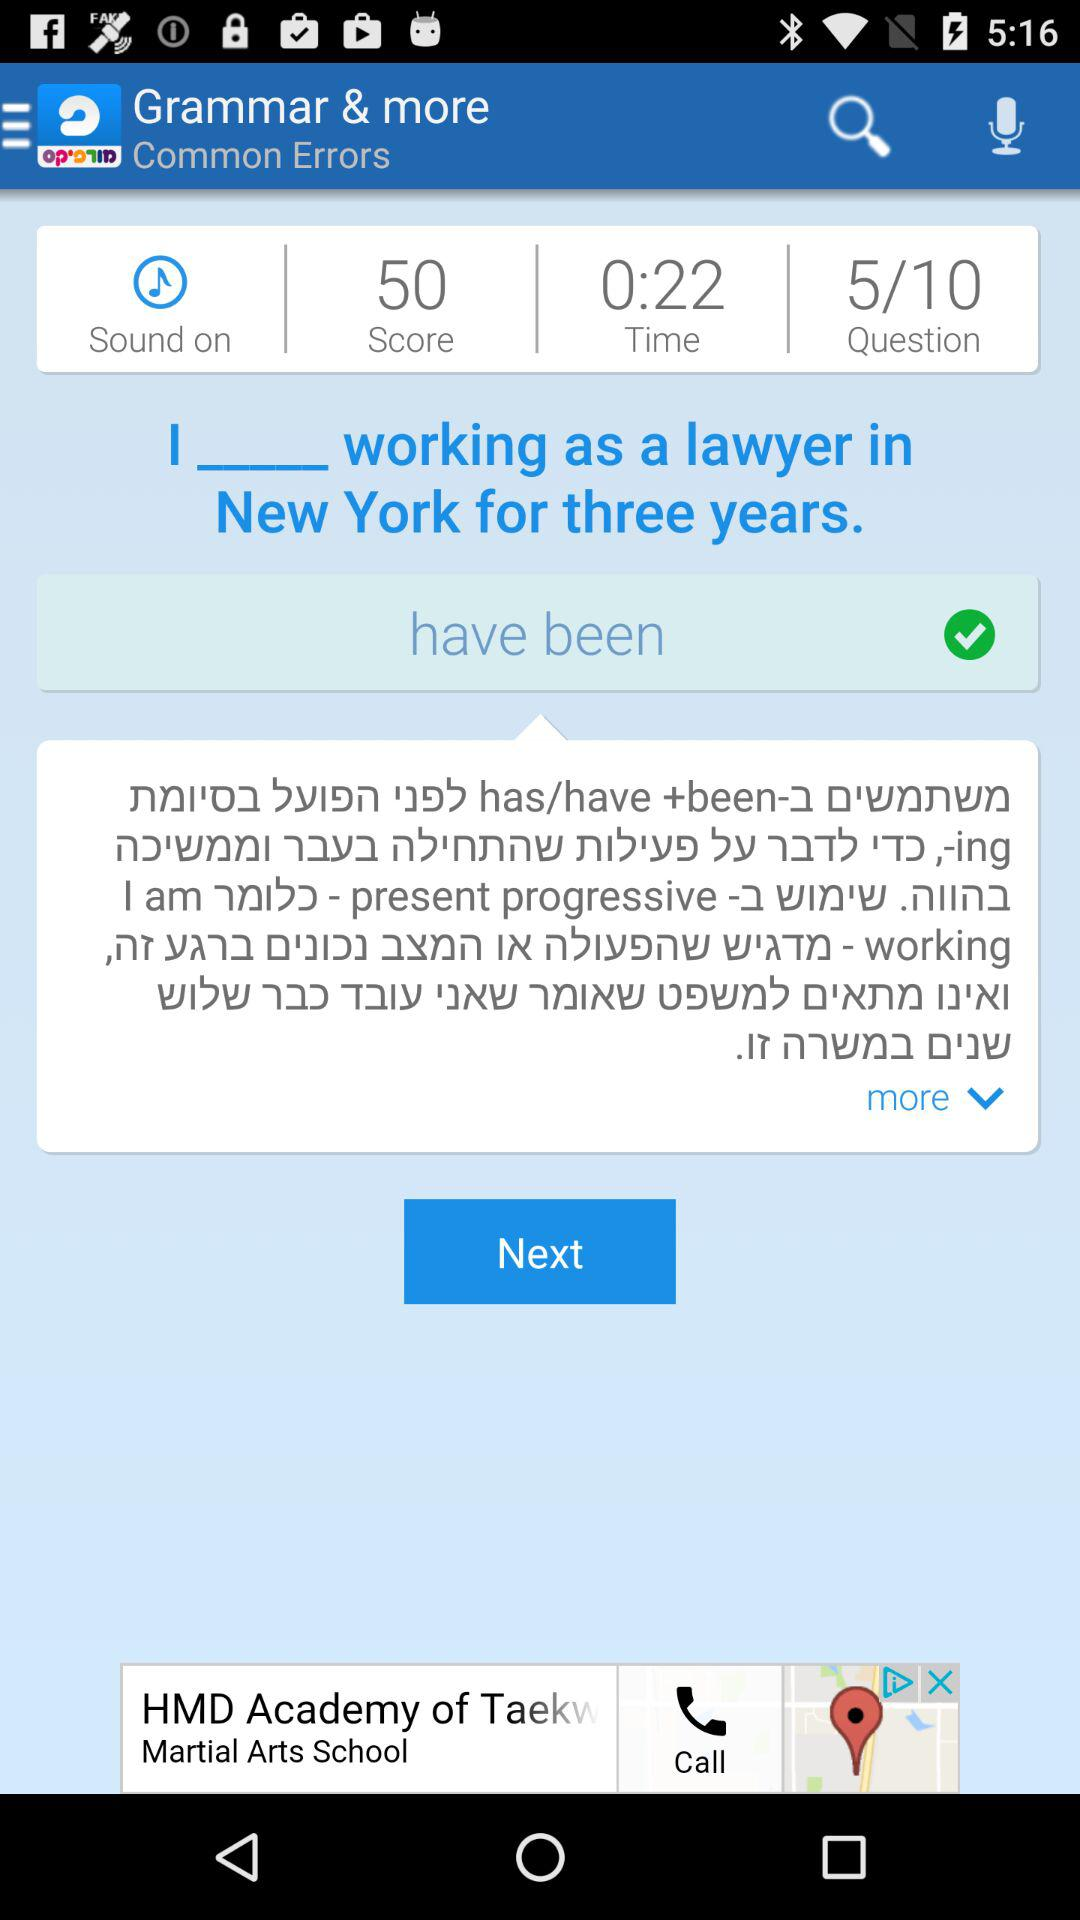What is the current status of "Sound"? The current status is "on". 